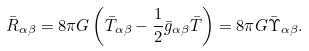<formula> <loc_0><loc_0><loc_500><loc_500>\bar { R } _ { \alpha \beta } = 8 \pi G \left ( \bar { T } _ { \alpha \beta } - \frac { 1 } { 2 } \bar { g } _ { \alpha \beta } \bar { T } \right ) = 8 \pi G \bar { \Upsilon } _ { \alpha \beta } .</formula> 